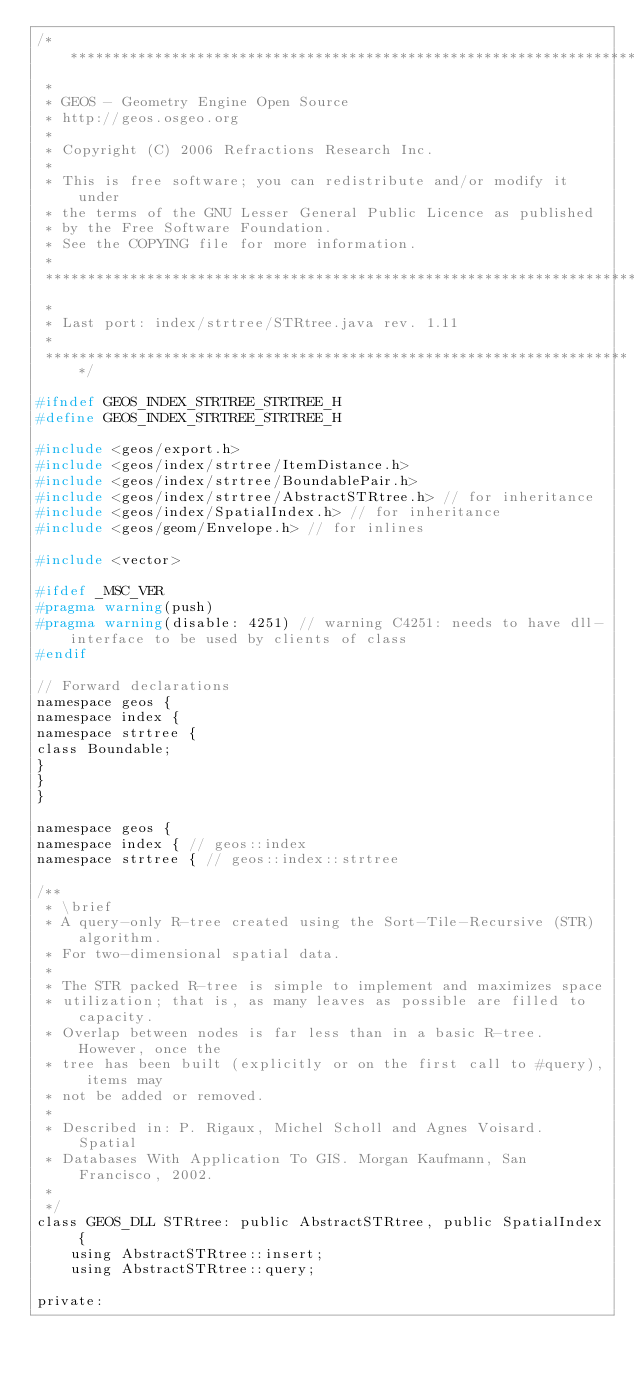Convert code to text. <code><loc_0><loc_0><loc_500><loc_500><_C_>/**********************************************************************
 *
 * GEOS - Geometry Engine Open Source
 * http://geos.osgeo.org
 *
 * Copyright (C) 2006 Refractions Research Inc.
 *
 * This is free software; you can redistribute and/or modify it under
 * the terms of the GNU Lesser General Public Licence as published
 * by the Free Software Foundation.
 * See the COPYING file for more information.
 *
 **********************************************************************
 *
 * Last port: index/strtree/STRtree.java rev. 1.11
 *
 **********************************************************************/

#ifndef GEOS_INDEX_STRTREE_STRTREE_H
#define GEOS_INDEX_STRTREE_STRTREE_H

#include <geos/export.h>
#include <geos/index/strtree/ItemDistance.h>
#include <geos/index/strtree/BoundablePair.h>
#include <geos/index/strtree/AbstractSTRtree.h> // for inheritance
#include <geos/index/SpatialIndex.h> // for inheritance
#include <geos/geom/Envelope.h> // for inlines

#include <vector>

#ifdef _MSC_VER
#pragma warning(push)
#pragma warning(disable: 4251) // warning C4251: needs to have dll-interface to be used by clients of class
#endif

// Forward declarations
namespace geos {
namespace index {
namespace strtree {
class Boundable;
}
}
}

namespace geos {
namespace index { // geos::index
namespace strtree { // geos::index::strtree

/**
 * \brief
 * A query-only R-tree created using the Sort-Tile-Recursive (STR) algorithm.
 * For two-dimensional spatial data.
 *
 * The STR packed R-tree is simple to implement and maximizes space
 * utilization; that is, as many leaves as possible are filled to capacity.
 * Overlap between nodes is far less than in a basic R-tree. However, once the
 * tree has been built (explicitly or on the first call to #query), items may
 * not be added or removed.
 *
 * Described in: P. Rigaux, Michel Scholl and Agnes Voisard. Spatial
 * Databases With Application To GIS. Morgan Kaufmann, San Francisco, 2002.
 *
 */
class GEOS_DLL STRtree: public AbstractSTRtree, public SpatialIndex {
    using AbstractSTRtree::insert;
    using AbstractSTRtree::query;

private:</code> 